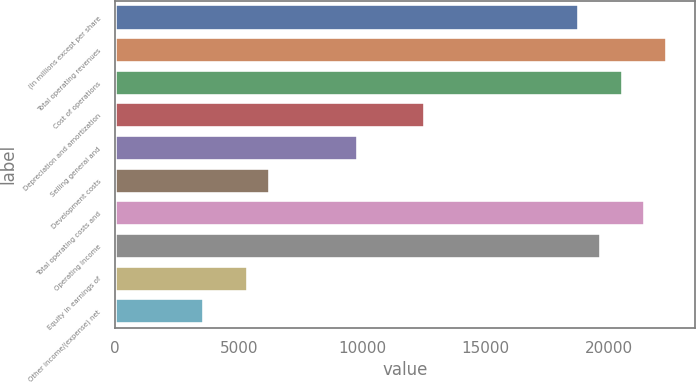Convert chart. <chart><loc_0><loc_0><loc_500><loc_500><bar_chart><fcel>(In millions except per share<fcel>Total operating revenues<fcel>Cost of operations<fcel>Depreciation and amortization<fcel>Selling general and<fcel>Development costs<fcel>Total operating costs and<fcel>Operating Income<fcel>Equity in earnings of<fcel>Other income/(expense) net<nl><fcel>18795.5<fcel>22374.9<fcel>20585.2<fcel>12531.5<fcel>9846.9<fcel>6267.46<fcel>21480.1<fcel>19690.4<fcel>5372.6<fcel>3582.88<nl></chart> 